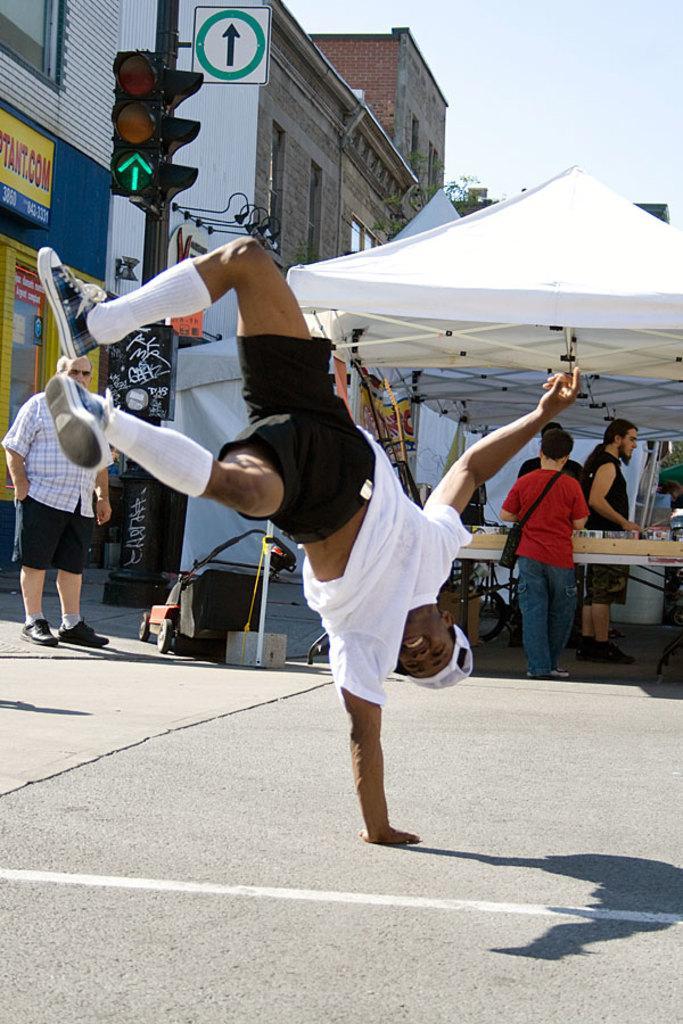Could you give a brief overview of what you see in this image? This picture describes about group of people, in the middle of the image we can see a man, he wore a white color T-shirt, in the background we can see few tents, buildings, sign boards, traffic lights and hoardings. 